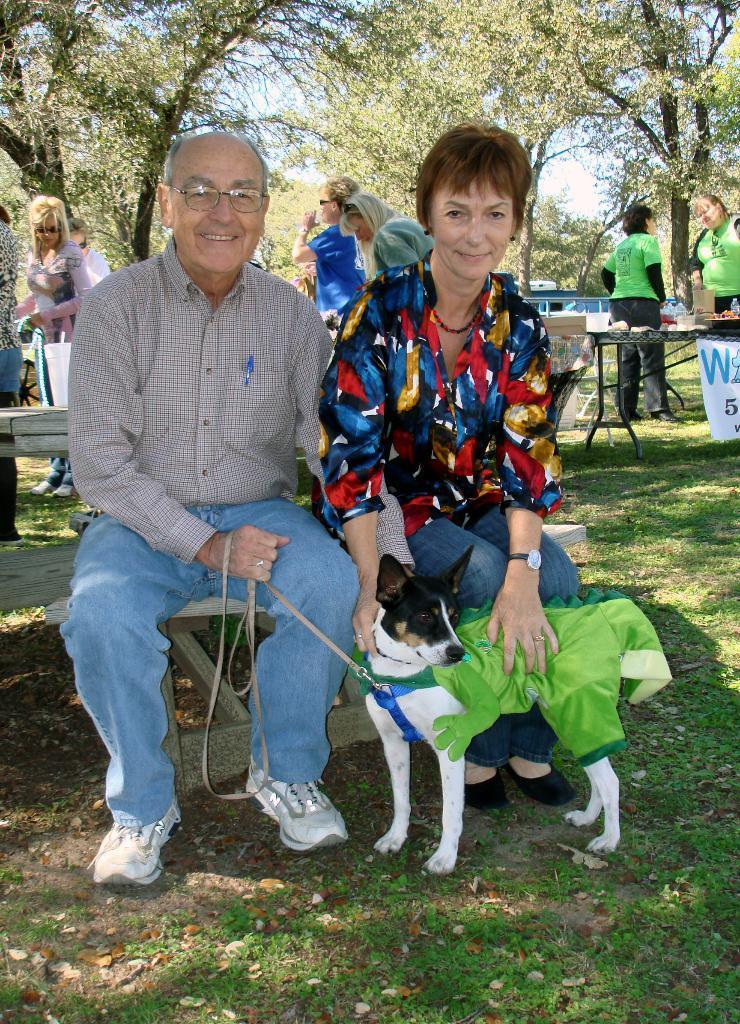In one or two sentences, can you explain what this image depicts? I think the image is taken in a garden. In the image there are two people both men and women are sitting on bench. Man is holding a dog, in background there are group of people standing in front of a table. On table we can see a water bottle and some food items we can also see a hoarding and trees and sky is on top. 